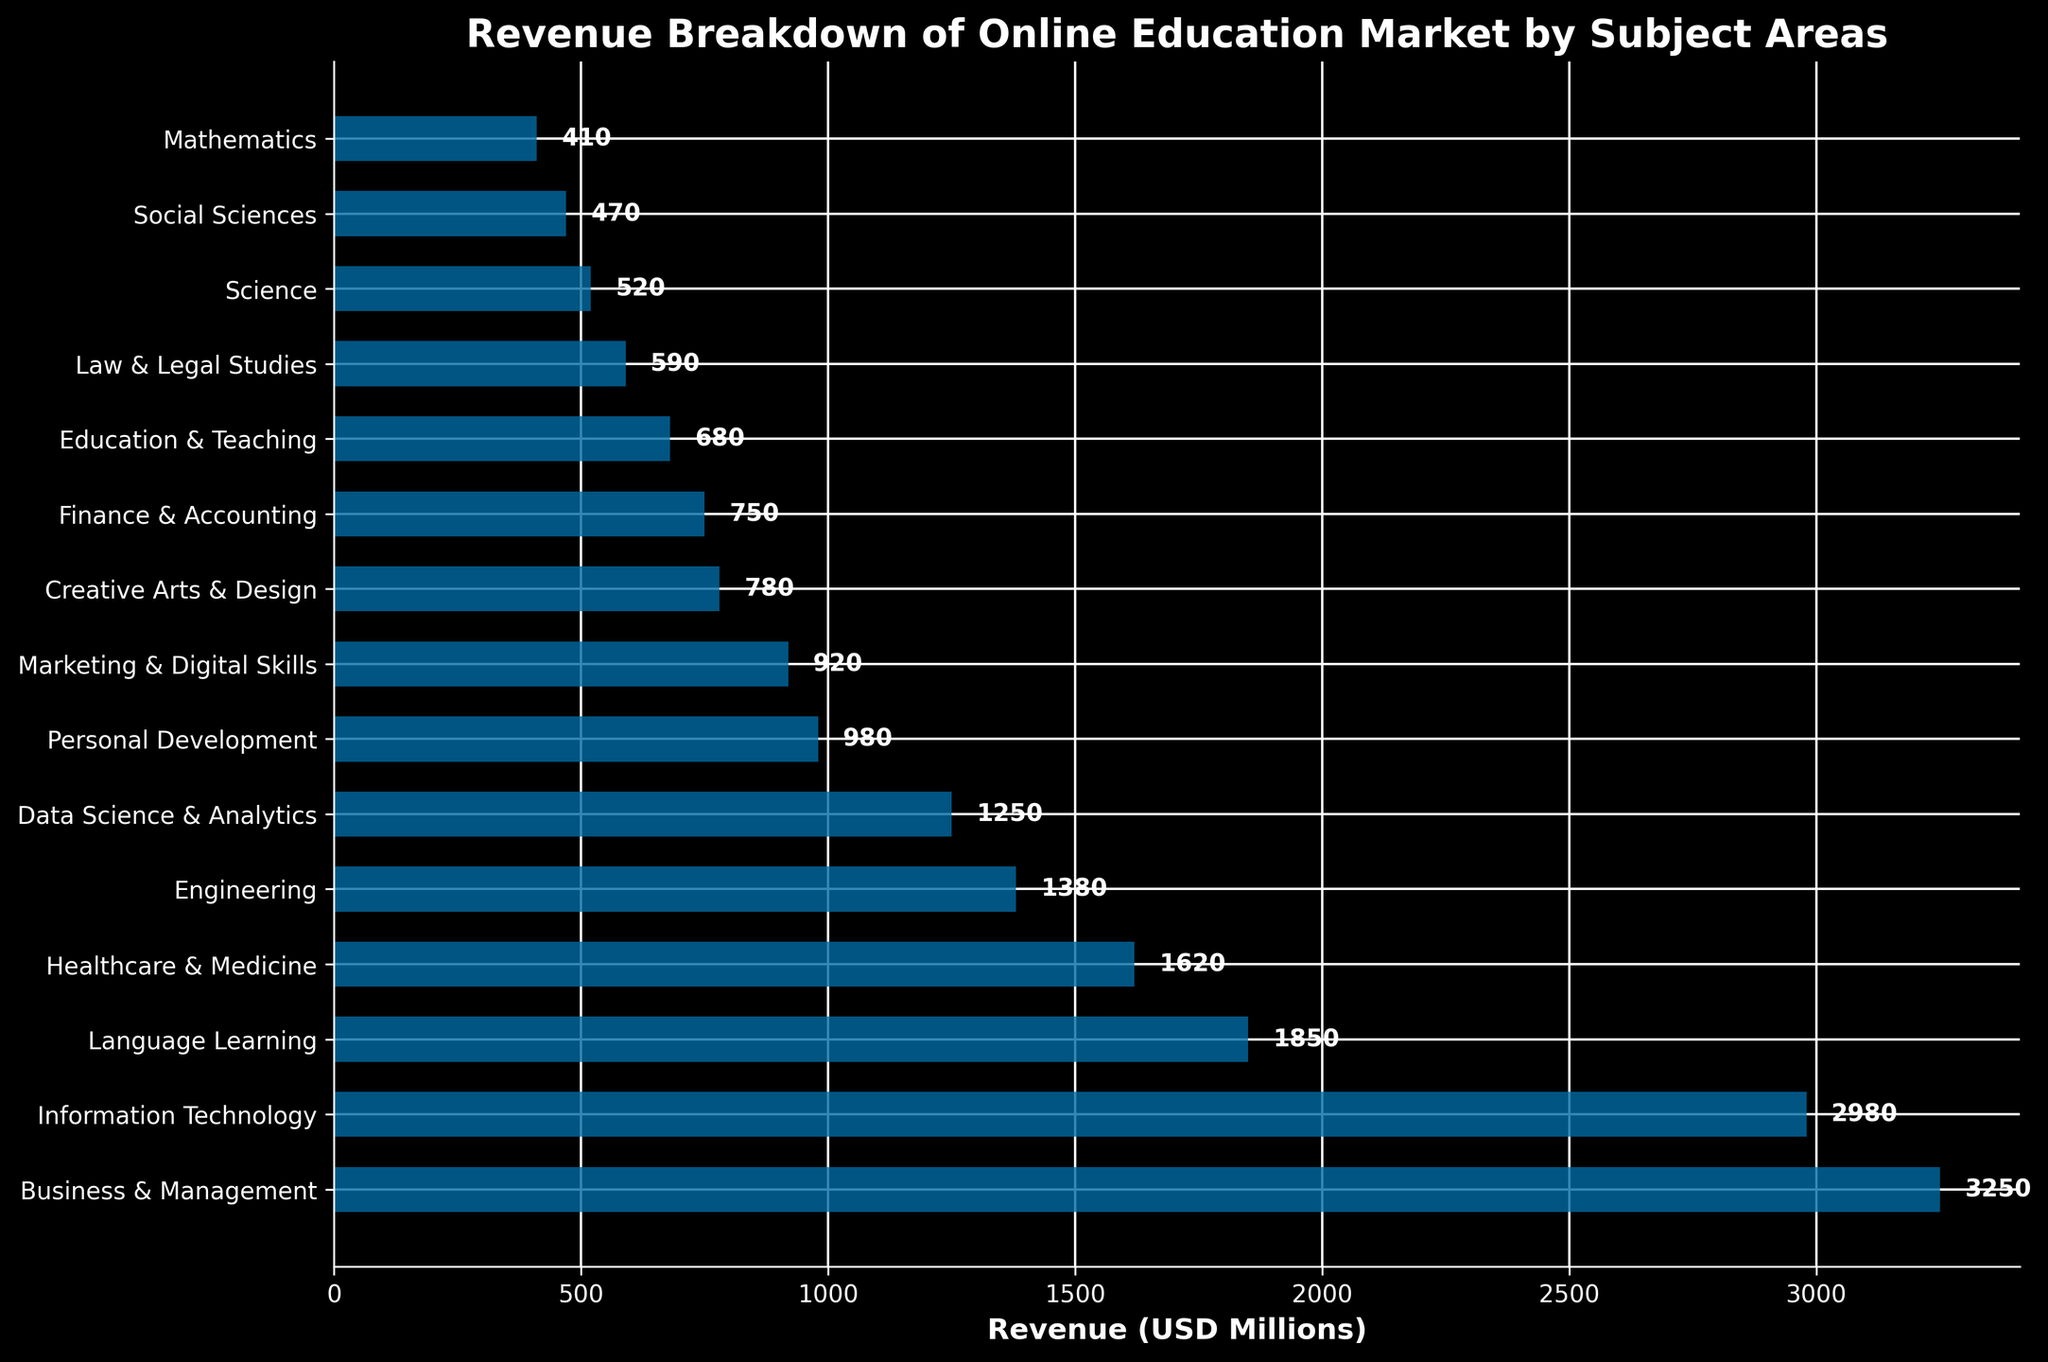Which subject area generated the highest revenue? The bar chart indicates the length of the bars for each subject area. The longest bar represents "Business & Management," confirming it has the highest revenue.
Answer: Business & Management Which subject area generated the lowest revenue? By examining the shortest bar, we see it corresponds to "Mathematics," indicating it generated the lowest revenue.
Answer: Mathematics What is the total revenue generated by Information Technology and Healthcare & Medicine? Add the revenues of Information Technology (2980) and Healthcare & Medicine (1620): 2980 + 1620 = 4600 USD Millions.
Answer: 4600 Compare the revenues of Marketing & Digital Skills and Finance & Accounting. Which is higher and by how much? Marketing & Digital Skills generated 920, while Finance & Accounting generated 750. Subtracting these: 920 - 750 = 170. So, Marketing & Digital Skills has a 170 USD Millions higher revenue.
Answer: Marketing & Digital Skills by 170 USD Millions What percent of total revenue is contributed by Data Science & Analytics? First, sum up the total revenues: 3250 + 2980 + 1850 + 1620 + 1380 + 1250 + 980 + 920 + 780 + 750 + 680 + 590 + 520 + 470 + 410 = 21630 USD Millions. Then calculate the percentage: (1250 / 21630) * 100 ≈ 5.78%.
Answer: ≈ 5.78% Is the revenue from Personal Development greater than the revenue from Social Sciences? Comparing the heights of "Personal Development" (980) and "Social Sciences" (470), it's clear that Personal Development has greater revenue.
Answer: Yes What is the average revenue of the top 3 highest-revenue subject areas? The top 3 are Business & Management (3250), Information Technology (2980), and Language Learning (1850). Average is: (3250 + 2980 + 1850) / 3 ≈ 2693.33 USD Millions.
Answer: ≈ 2693.33 USD Millions What’s the difference in revenue between Creative Arts & Design and Engineering? Creative Arts & Design generated 780, while Engineering generated 1380. Subtracting these: 1380 - 780 = 600.
Answer: 600 Which subject has a revenue closest to 900 USD Millions? Examining the bars, "Marketing & Digital Skills" has 920 USD Millions, which is closest to 900 USD Millions.
Answer: Marketing & Digital Skills What is the combined revenue of the three lowest-revenue subject areas? The three lowest-revenue areas are Social Sciences (470), Mathematics (410), and Science (520). Combined revenue: 470 + 410 + 520 = 1400 USD Millions.
Answer: 1400 